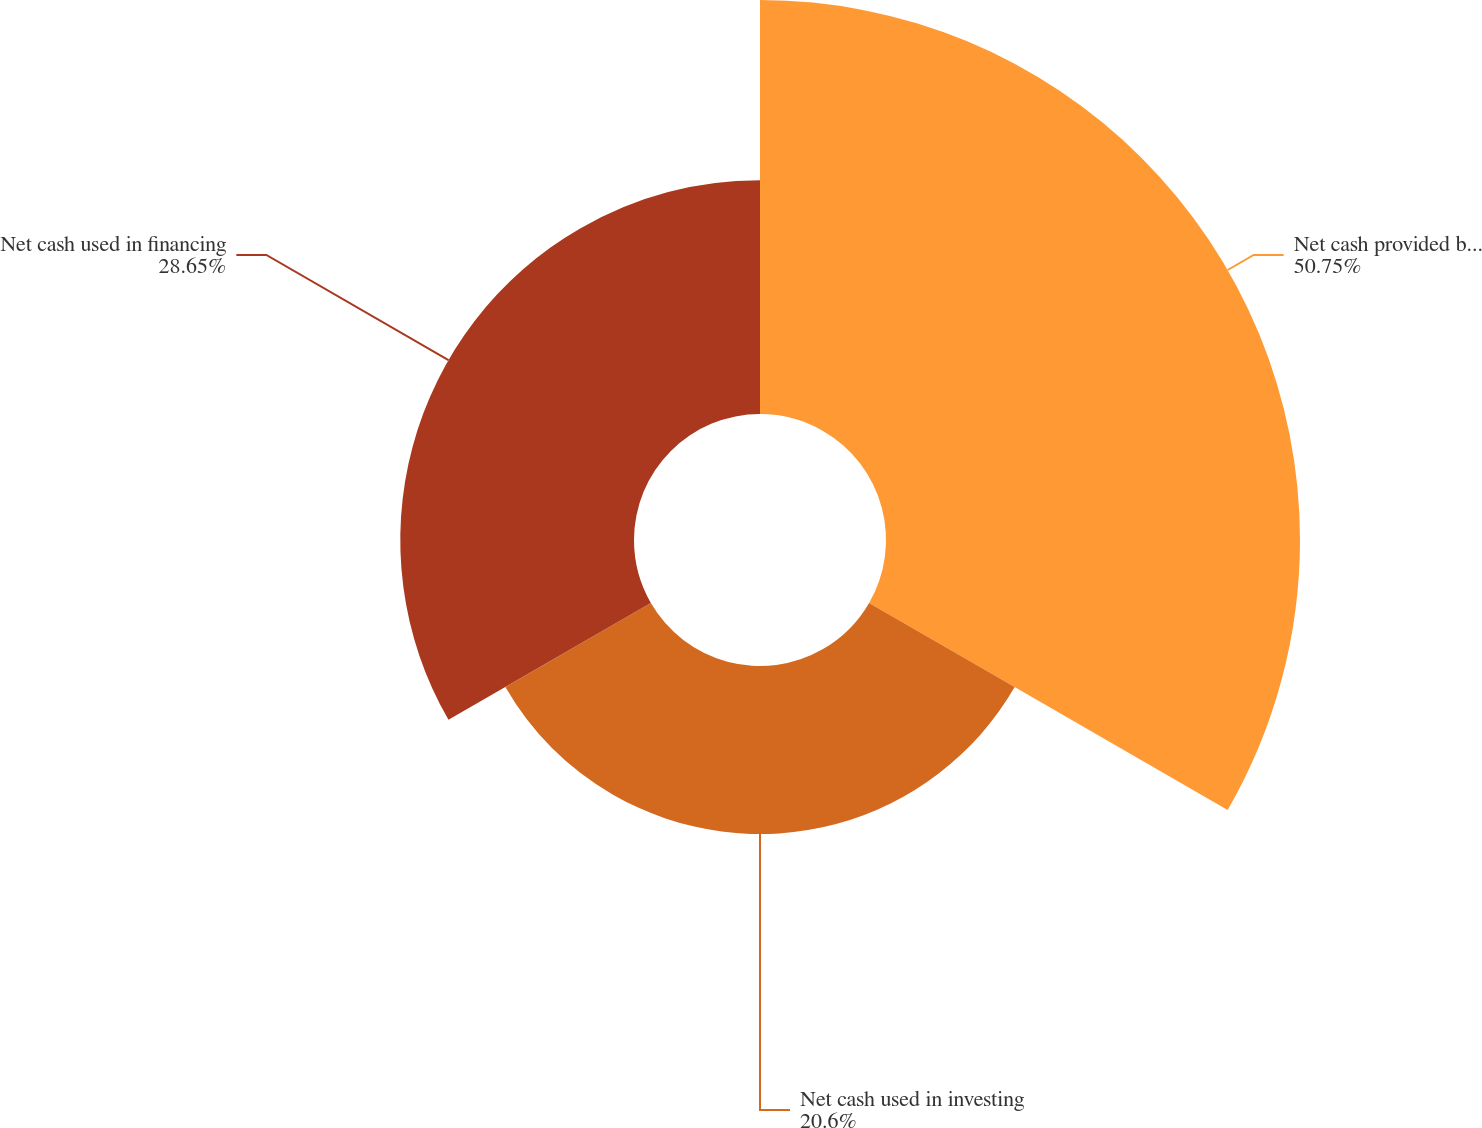Convert chart to OTSL. <chart><loc_0><loc_0><loc_500><loc_500><pie_chart><fcel>Net cash provided by operating<fcel>Net cash used in investing<fcel>Net cash used in financing<nl><fcel>50.75%<fcel>20.6%<fcel>28.65%<nl></chart> 